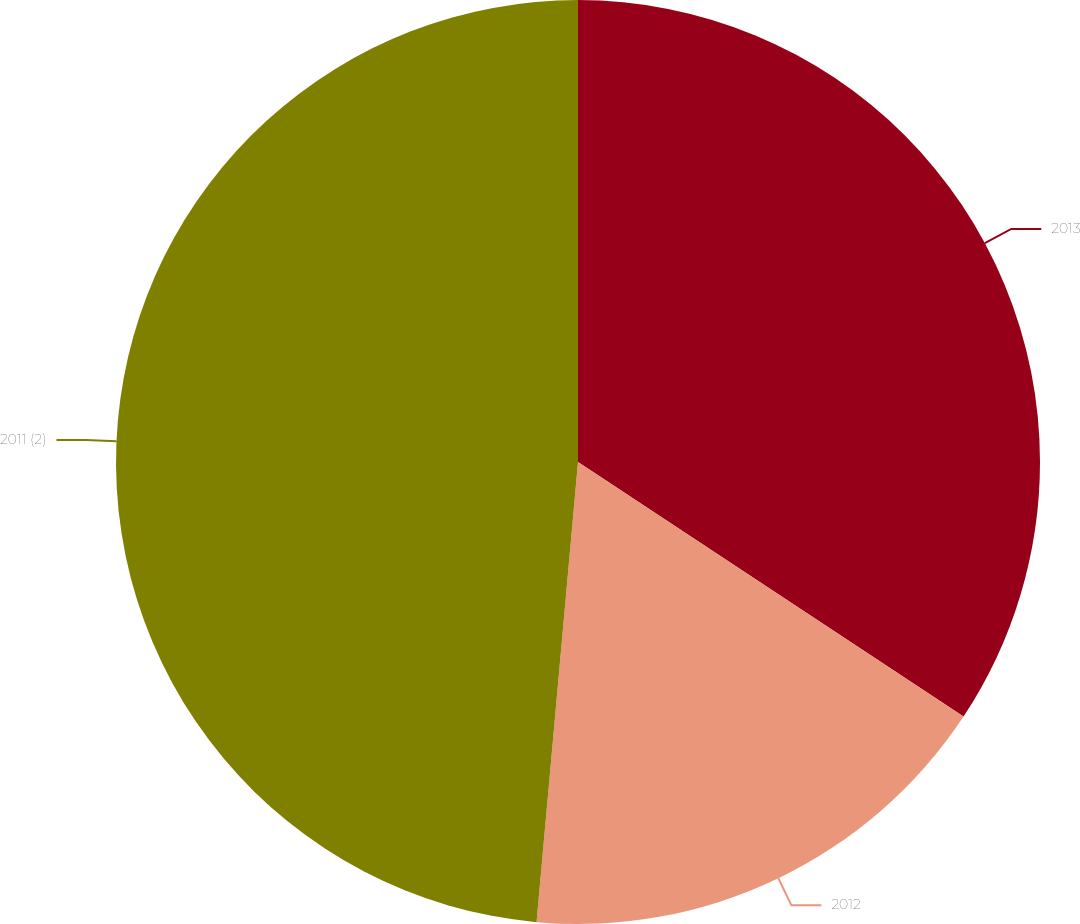Convert chart. <chart><loc_0><loc_0><loc_500><loc_500><pie_chart><fcel>2013<fcel>2012<fcel>2011 (2)<nl><fcel>34.29%<fcel>17.14%<fcel>48.57%<nl></chart> 